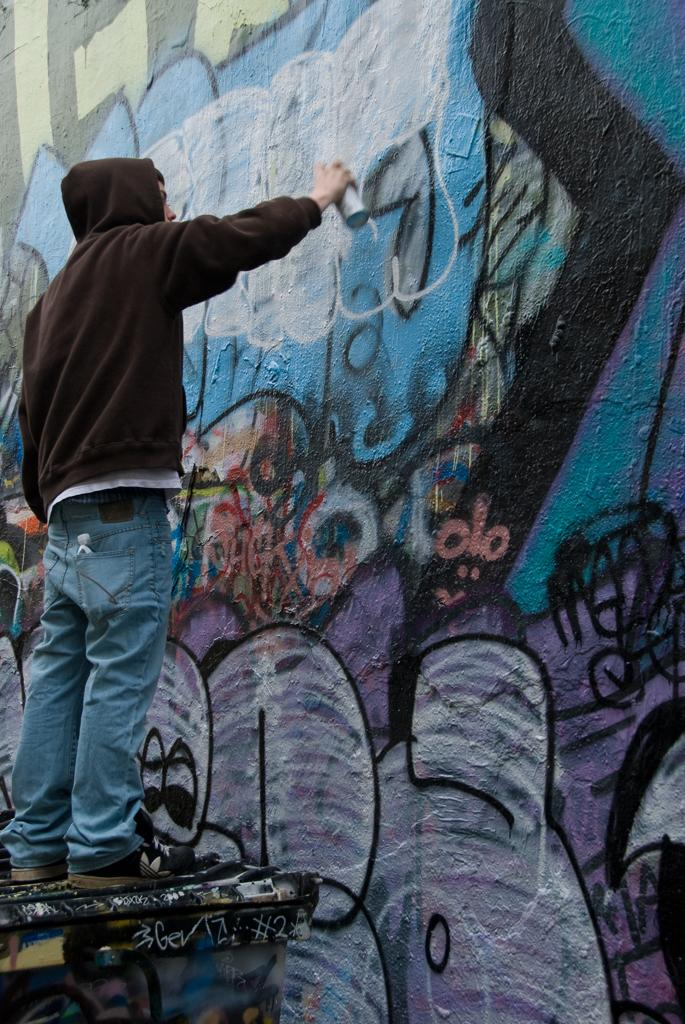What is the main subject of the image? There is a person in the image. Where is the person located in the image? The person is standing on the left side. What is the person holding in the image? The person is holding a container. What activity is the person engaged in? The person is doing graffiti on a wall. How many clocks can be seen hanging on the wall in the image? There are no clocks visible in the image; it features a person doing graffiti on a wall. Is the queen present in the image? There is no reference to a queen or any royal figure in the image. 